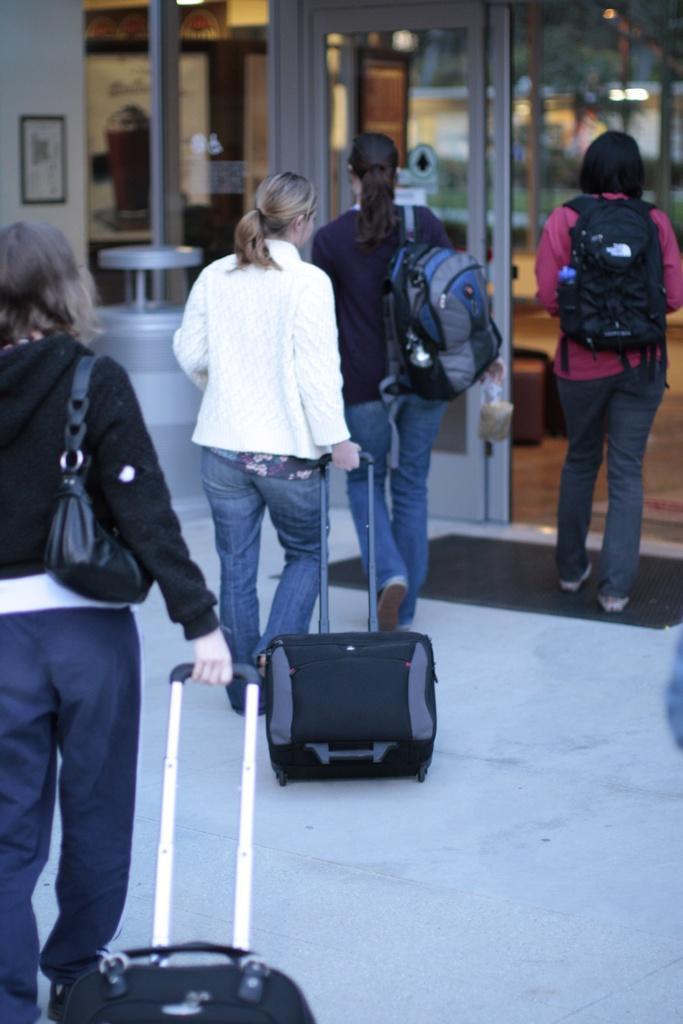How many ladies are present in the image? There are four ladies in the image. What are the ladies doing in the image? The ladies are walking. What are the ladies holding in the image? The ladies are holding bags. What can be seen in the background of the image? There is a door, a wall with a photo frame, and pillars in the background of the image. What type of bean is growing on the wall in the image? There are no beans present in the image; the wall has a photo frame instead. How many arms are visible in the image? The number of arms visible in the image cannot be determined from the provided facts, as it depends on the number of arms each lady has and how they are positioned. 